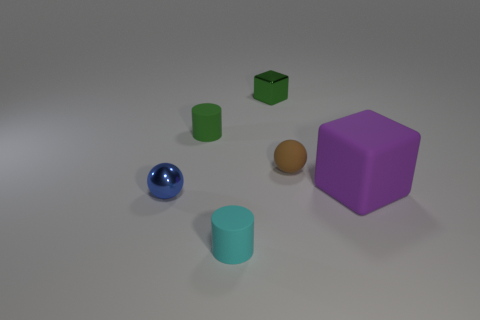Add 4 tiny matte objects. How many objects exist? 10 Subtract all blocks. How many objects are left? 4 Subtract 1 green blocks. How many objects are left? 5 Subtract all red metal cubes. Subtract all green objects. How many objects are left? 4 Add 2 tiny cyan rubber cylinders. How many tiny cyan rubber cylinders are left? 3 Add 6 small green rubber things. How many small green rubber things exist? 7 